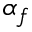Convert formula to latex. <formula><loc_0><loc_0><loc_500><loc_500>\alpha _ { f }</formula> 